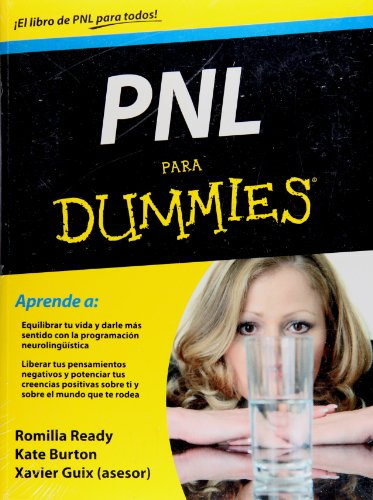What does the subtitle 'Aprende a:' on the book indicate about its content? The subtitle 'Aprende a:' translates to 'Learn to:' in English, and it's followed by a list that typically would summarize key outcomes or skills the reader can expect to gain from the book. It suggests an educational approach, encouraging readers to learn practical NLP techniques to improve their life quality. 